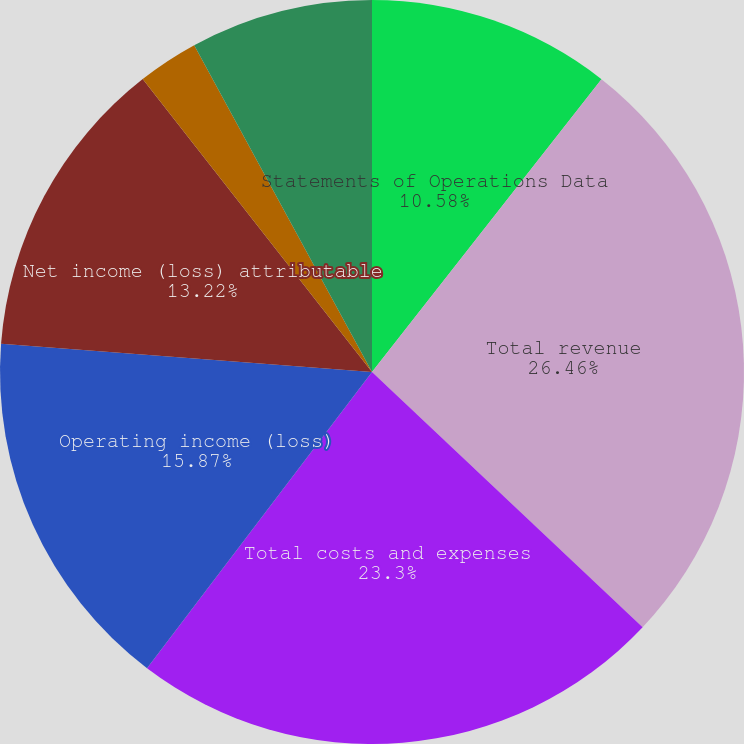Convert chart to OTSL. <chart><loc_0><loc_0><loc_500><loc_500><pie_chart><fcel>Statements of Operations Data<fcel>Total revenue<fcel>Total costs and expenses<fcel>Operating income (loss)<fcel>Net income (loss) attributable<fcel>Basic net income (loss) per<fcel>Diluted net income (loss) per<nl><fcel>10.58%<fcel>26.45%<fcel>23.3%<fcel>15.87%<fcel>13.22%<fcel>2.64%<fcel>7.93%<nl></chart> 